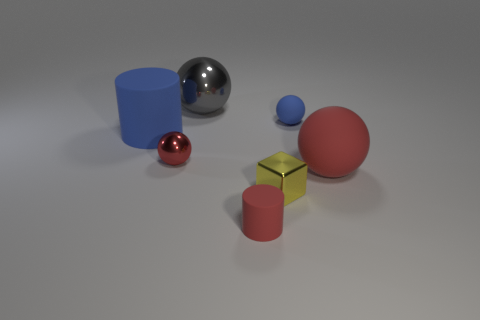Add 2 blue rubber spheres. How many objects exist? 9 Subtract all gray spheres. How many spheres are left? 3 Subtract 3 balls. How many balls are left? 1 Subtract all blue spheres. How many spheres are left? 3 Subtract all cylinders. How many objects are left? 5 Subtract all brown spheres. Subtract all purple cylinders. How many spheres are left? 4 Subtract all blue cylinders. How many gray spheres are left? 1 Subtract all big cyan cylinders. Subtract all large spheres. How many objects are left? 5 Add 1 yellow blocks. How many yellow blocks are left? 2 Add 4 green blocks. How many green blocks exist? 4 